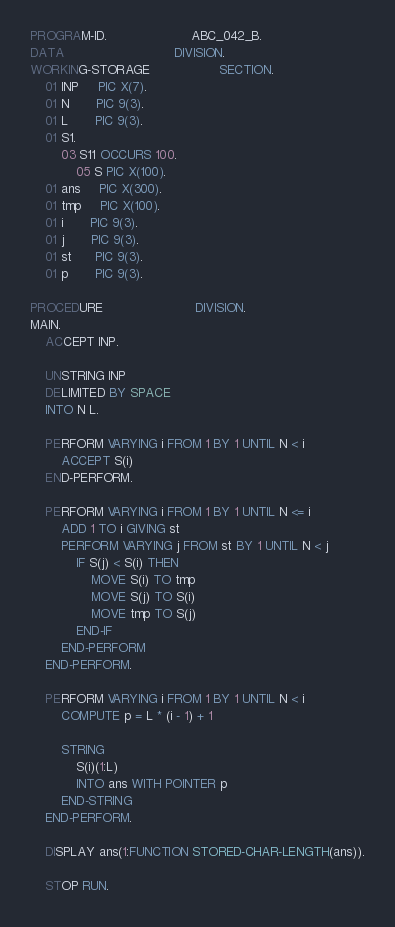<code> <loc_0><loc_0><loc_500><loc_500><_COBOL_>PROGRAM-ID.                      ABC_042_B.
DATA                             DIVISION.
WORKING-STORAGE                  SECTION.
    01 INP     PIC X(7).
    01 N       PIC 9(3).
    01 L       PIC 9(3).
    01 S1.
        03 S11 OCCURS 100.
            05 S PIC X(100).
    01 ans     PIC X(300).
    01 tmp     PIC X(100).
    01 i       PIC 9(3).
    01 j       PIC 9(3).
    01 st      PIC 9(3).
    01 p       PIC 9(3).

PROCEDURE                        DIVISION.
MAIN.
    ACCEPT INP.

    UNSTRING INP
    DELIMITED BY SPACE
    INTO N L.

    PERFORM VARYING i FROM 1 BY 1 UNTIL N < i
        ACCEPT S(i)
    END-PERFORM.

    PERFORM VARYING i FROM 1 BY 1 UNTIL N <= i
        ADD 1 TO i GIVING st
        PERFORM VARYING j FROM st BY 1 UNTIL N < j
            IF S(j) < S(i) THEN
                MOVE S(i) TO tmp
                MOVE S(j) TO S(i)
                MOVE tmp TO S(j)
            END-IF
        END-PERFORM
    END-PERFORM.

    PERFORM VARYING i FROM 1 BY 1 UNTIL N < i
        COMPUTE p = L * (i - 1) + 1

        STRING
            S(i)(1:L)
            INTO ans WITH POINTER p
        END-STRING
    END-PERFORM.

    DISPLAY ans(1:FUNCTION STORED-CHAR-LENGTH(ans)).

    STOP RUN.
</code> 